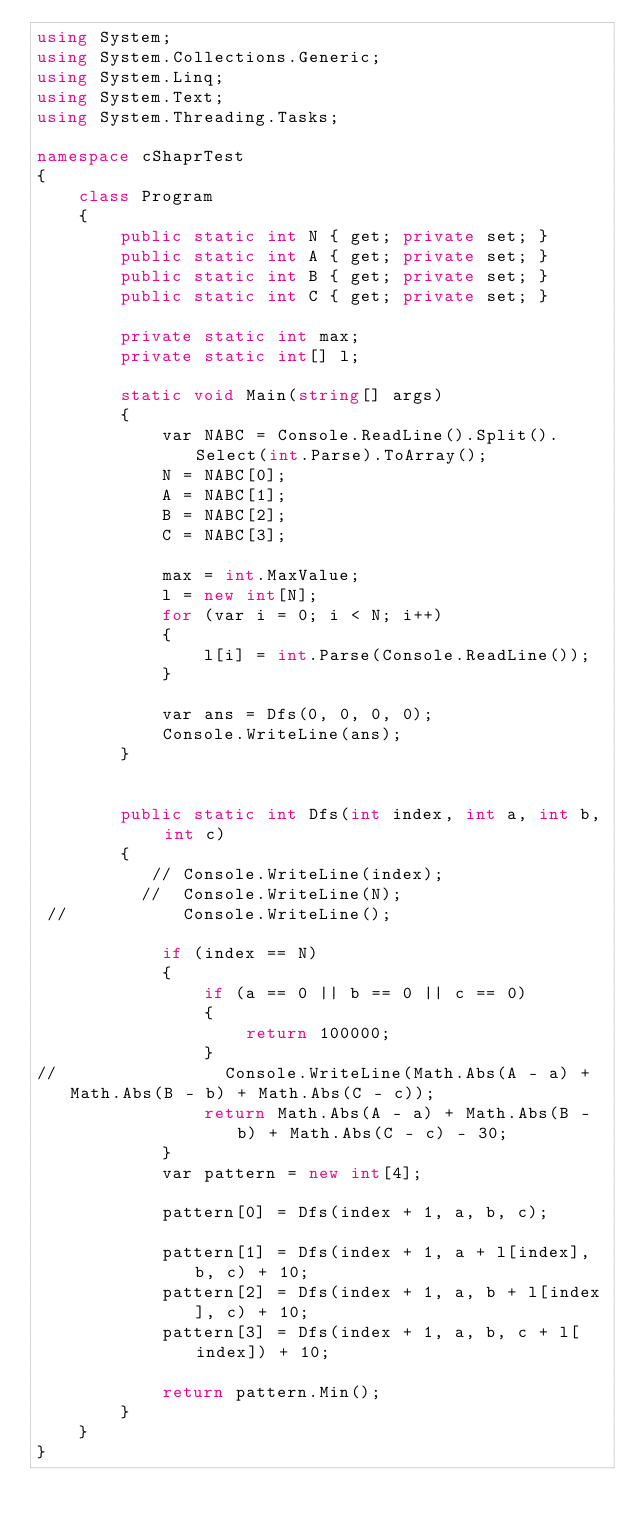<code> <loc_0><loc_0><loc_500><loc_500><_C#_>using System;
using System.Collections.Generic;
using System.Linq;
using System.Text;
using System.Threading.Tasks;

namespace cShaprTest
{
    class Program
    {
        public static int N { get; private set; }
        public static int A { get; private set; }
        public static int B { get; private set; }
        public static int C { get; private set; }

        private static int max;
        private static int[] l;

        static void Main(string[] args)
        {
            var NABC = Console.ReadLine().Split().Select(int.Parse).ToArray();
            N = NABC[0];
            A = NABC[1];
            B = NABC[2];
            C = NABC[3];

            max = int.MaxValue;
            l = new int[N];
            for (var i = 0; i < N; i++)
            {
                l[i] = int.Parse(Console.ReadLine());
            }

            var ans = Dfs(0, 0, 0, 0);
            Console.WriteLine(ans);
        }


        public static int Dfs(int index, int a, int b, int c)
        {
           // Console.WriteLine(index);
          //  Console.WriteLine(N);
 //           Console.WriteLine();

            if (index == N)
            {
                if (a == 0 || b == 0 || c == 0)
                {
                    return 100000;
                }
//                Console.WriteLine(Math.Abs(A - a) + Math.Abs(B - b) + Math.Abs(C - c));
                return Math.Abs(A - a) + Math.Abs(B - b) + Math.Abs(C - c) - 30;
            }
            var pattern = new int[4];

            pattern[0] = Dfs(index + 1, a, b, c);

            pattern[1] = Dfs(index + 1, a + l[index], b, c) + 10;
            pattern[2] = Dfs(index + 1, a, b + l[index], c) + 10;
            pattern[3] = Dfs(index + 1, a, b, c + l[index]) + 10;

            return pattern.Min();
        }
    }
}
</code> 